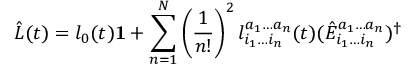<formula> <loc_0><loc_0><loc_500><loc_500>\hat { L } ( t ) = l _ { 0 } ( t ) 1 + \sum _ { n = 1 } ^ { N } \left ( \frac { 1 } { n ! } \right ) ^ { 2 } l _ { i _ { 1 } \dots i _ { n } } ^ { a _ { 1 } \dots a _ { n } } ( t ) ( \hat { E } _ { i _ { 1 } \dots i _ { n } } ^ { a _ { 1 } \dots a _ { n } } ) ^ { \dagger }</formula> 